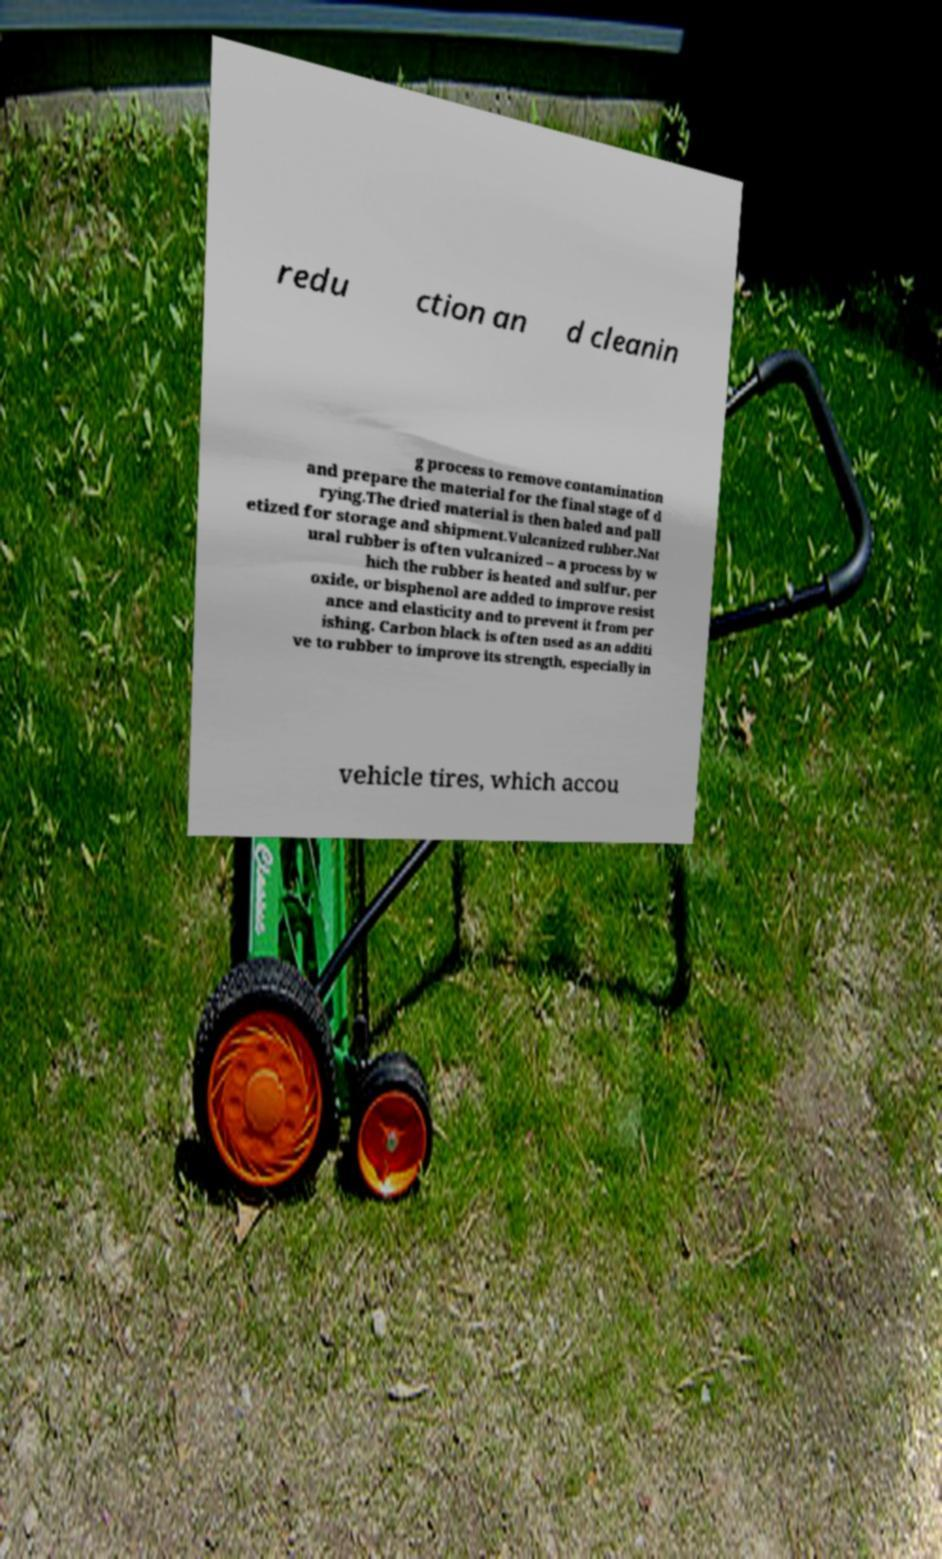For documentation purposes, I need the text within this image transcribed. Could you provide that? redu ction an d cleanin g process to remove contamination and prepare the material for the final stage of d rying.The dried material is then baled and pall etized for storage and shipment.Vulcanized rubber.Nat ural rubber is often vulcanized – a process by w hich the rubber is heated and sulfur, per oxide, or bisphenol are added to improve resist ance and elasticity and to prevent it from per ishing. Carbon black is often used as an additi ve to rubber to improve its strength, especially in vehicle tires, which accou 